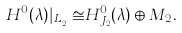<formula> <loc_0><loc_0><loc_500><loc_500>H ^ { 0 } ( \lambda ) | _ { L _ { J _ { 2 } } } \cong H ^ { 0 } _ { J _ { 2 } } ( \lambda ) \oplus M _ { 2 } .</formula> 